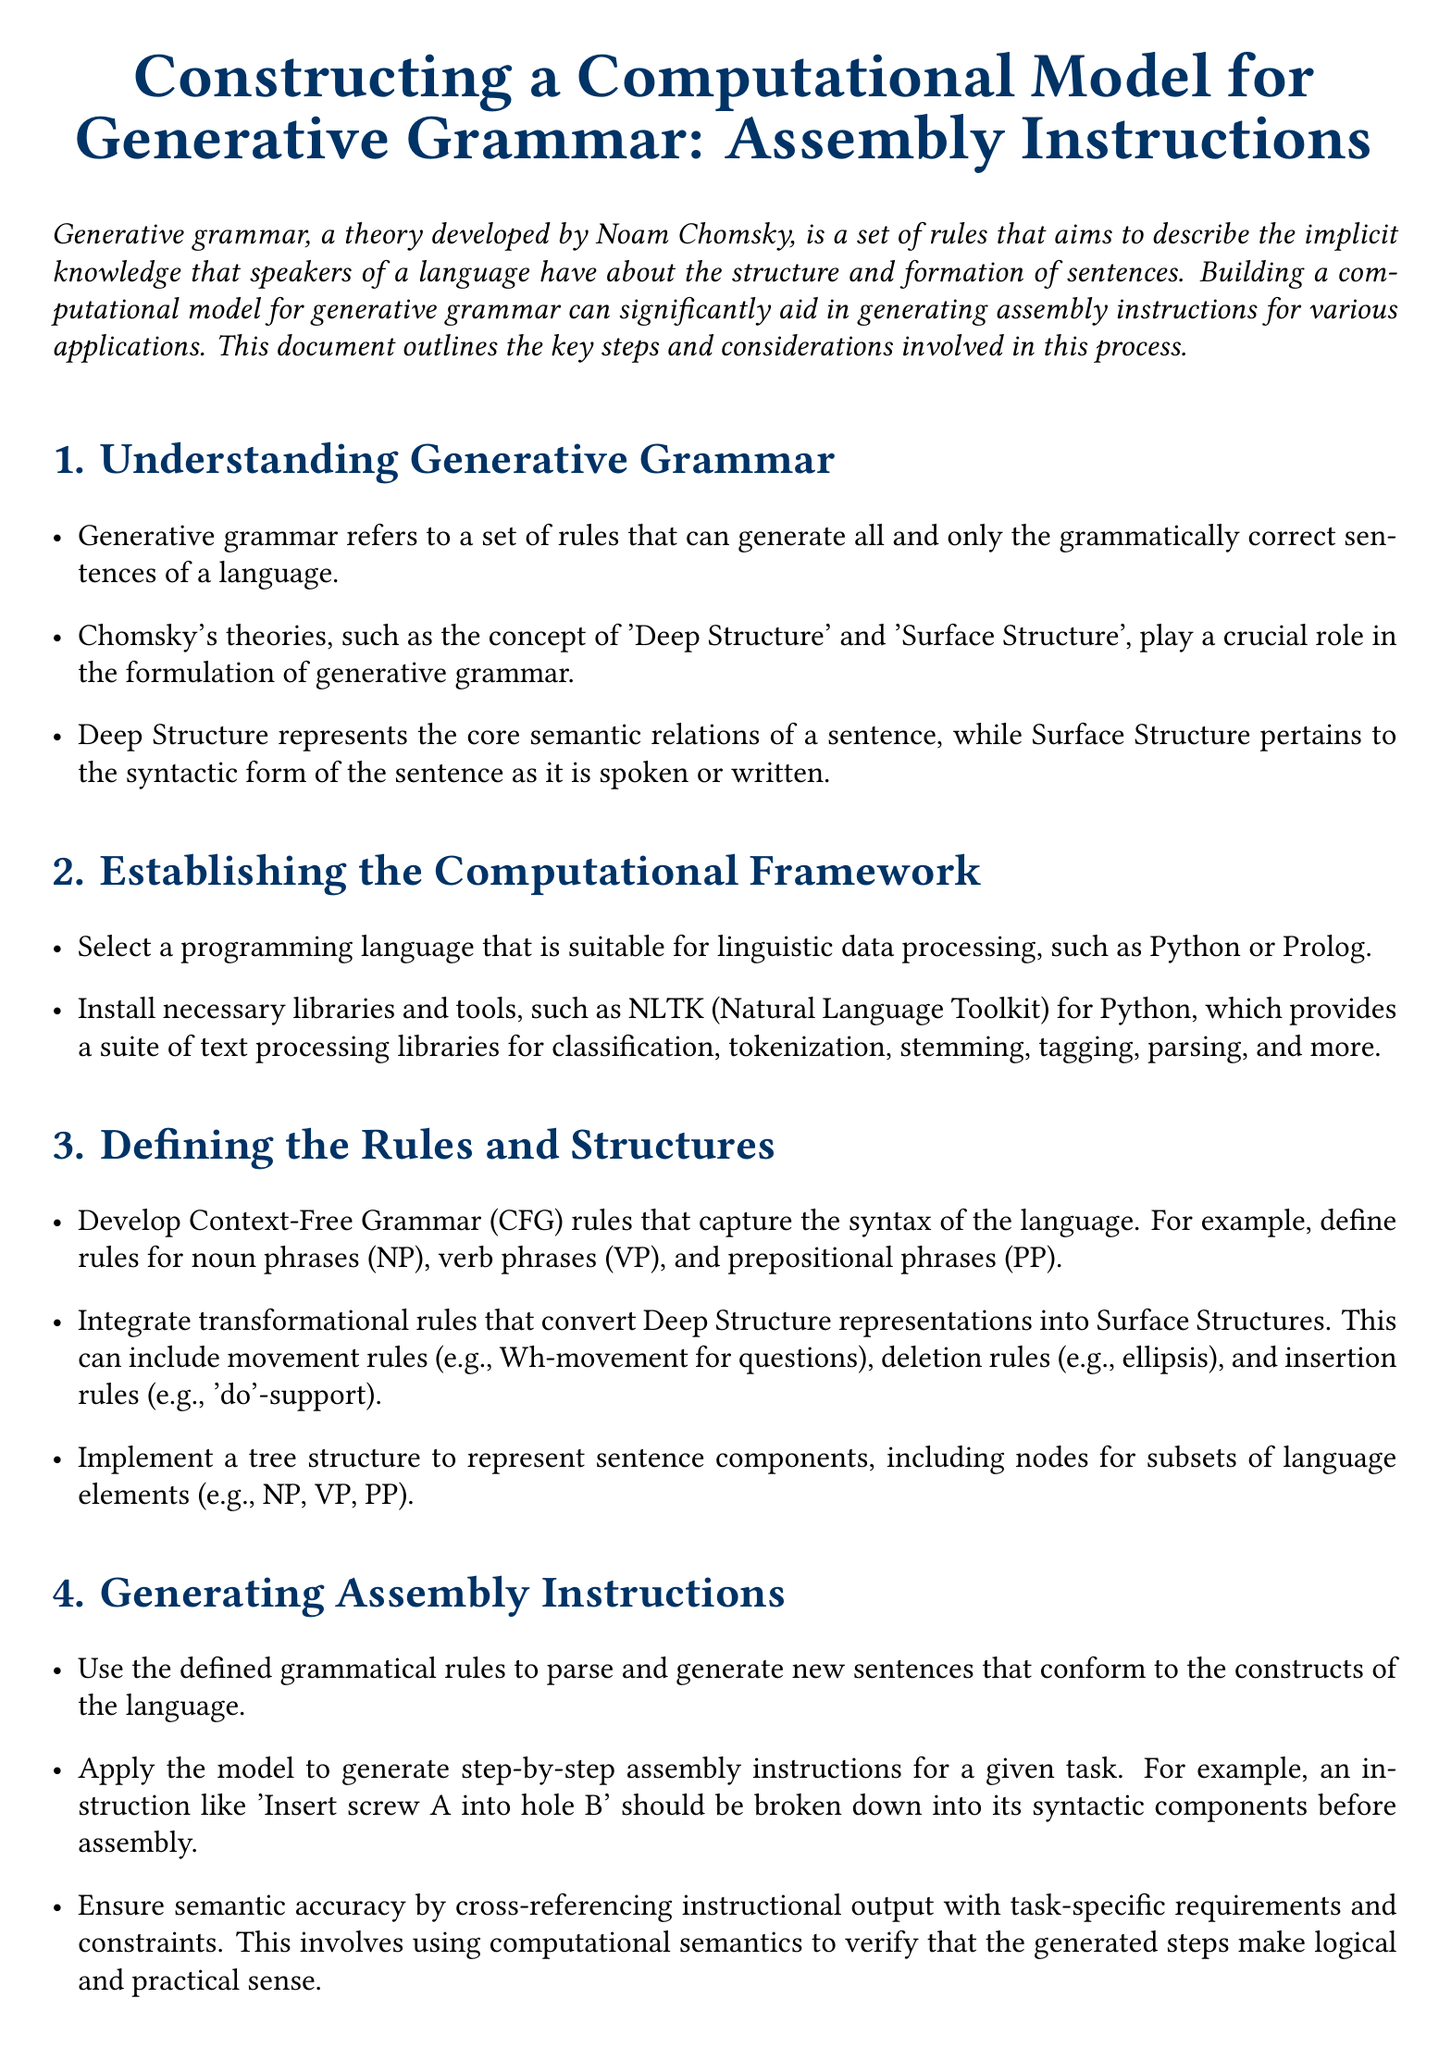What is the title of the document? The title of the document is stated at the beginning, detailing the main focus of the instructions.
Answer: Constructing a Computational Model for Generative Grammar: Assembly Instructions Who developed the theory of generative grammar? The document attributes the development of generative grammar to a specific well-known linguist.
Answer: Noam Chomsky What programming language is suggested for linguistic data processing? The document mentions suitable programming languages for the computational framework.
Answer: Python or Prolog What does CFG stand for in the document? The document uses this abbreviation when discussing rules that capture the syntax of the language.
Answer: Context-Free Grammar What role do transformational rules play in the model? These rules are described in the document as necessary for converting Deep Structure representations into Surface Structures.
Answer: Convert Deep Structure representations How should generated instructions be evaluated? The document specifies how to assess the accuracy and efficiency of the model's output.
Answer: Comparing with human-generated instructions What is the first step in constructing the computational model? The document outlines a clear sequence of steps for building the model, starting with the foundational concept.
Answer: Understanding Generative Grammar What is integrated into the tree structure representing sentence components? The document describes components that are part of the tree structure used in the model.
Answer: Nodes for subsets of language elements What is crucial for ensuring semantic accuracy? The text highlights the importance of this process in verifying the logical soundness of generated steps.
Answer: Cross-referencing instructional output 